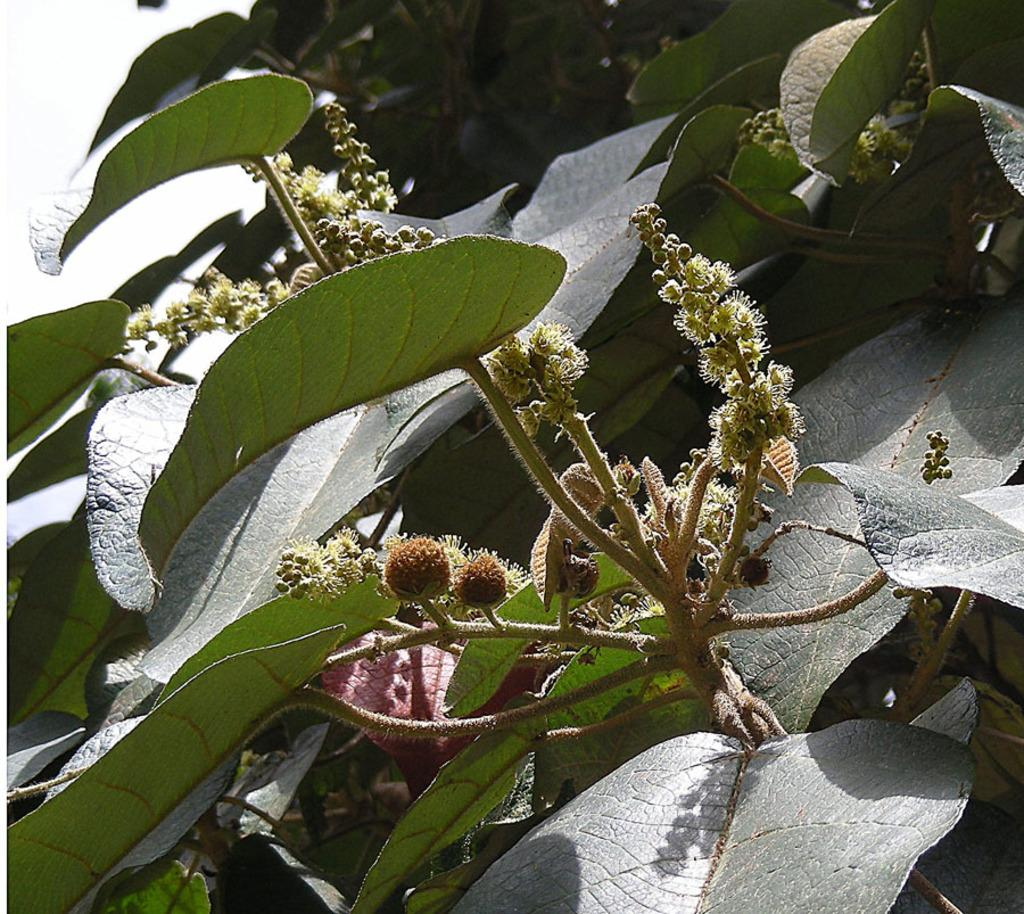What type of living organism is present in the image? There is a plant in the picture. Can you describe the plant's appearance? The plant has many leaves and a stem. It also has pine-like structures. How many firemen are climbing the plant in the image? There are no firemen present in the image; it features a plant with many leaves, a stem, and pine-like structures. What type of lizards can be seen crawling on the leaves of the plant in the image? There are no lizards present in the image; it features a plant with many leaves, a stem, and pine-like structures. 